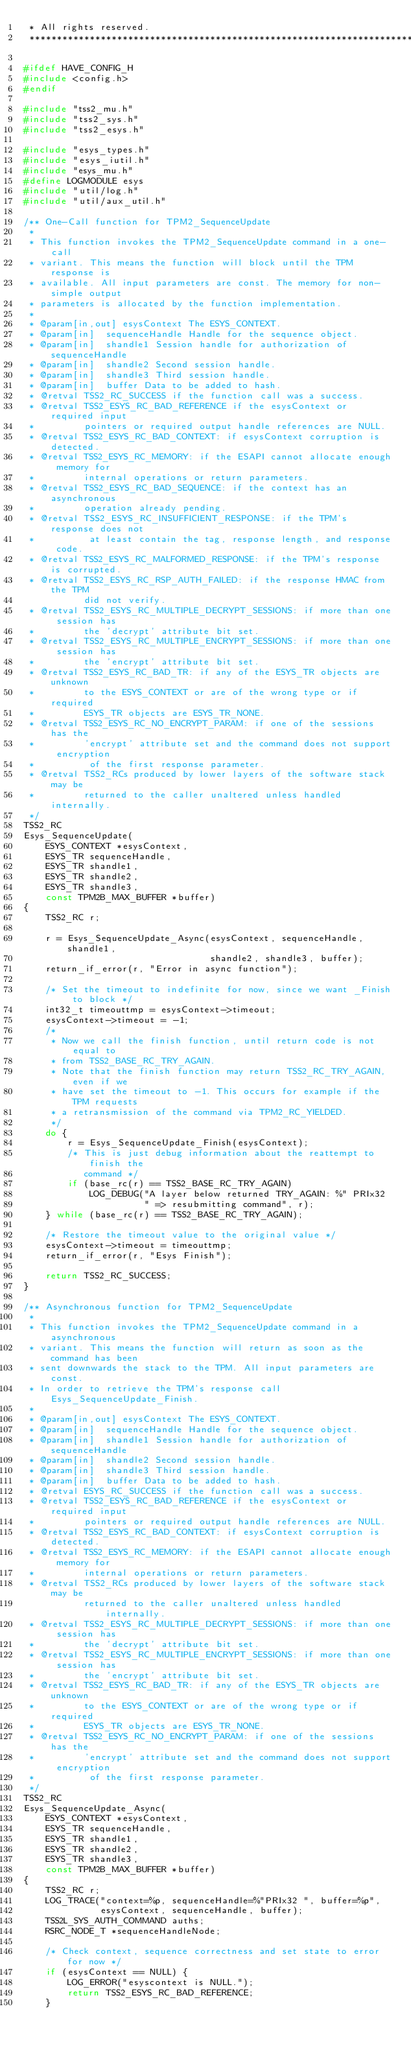<code> <loc_0><loc_0><loc_500><loc_500><_C_> * All rights reserved.
 ******************************************************************************/

#ifdef HAVE_CONFIG_H
#include <config.h>
#endif

#include "tss2_mu.h"
#include "tss2_sys.h"
#include "tss2_esys.h"

#include "esys_types.h"
#include "esys_iutil.h"
#include "esys_mu.h"
#define LOGMODULE esys
#include "util/log.h"
#include "util/aux_util.h"

/** One-Call function for TPM2_SequenceUpdate
 *
 * This function invokes the TPM2_SequenceUpdate command in a one-call
 * variant. This means the function will block until the TPM response is
 * available. All input parameters are const. The memory for non-simple output
 * parameters is allocated by the function implementation.
 *
 * @param[in,out] esysContext The ESYS_CONTEXT.
 * @param[in]  sequenceHandle Handle for the sequence object.
 * @param[in]  shandle1 Session handle for authorization of sequenceHandle
 * @param[in]  shandle2 Second session handle.
 * @param[in]  shandle3 Third session handle.
 * @param[in]  buffer Data to be added to hash.
 * @retval TSS2_RC_SUCCESS if the function call was a success.
 * @retval TSS2_ESYS_RC_BAD_REFERENCE if the esysContext or required input
 *         pointers or required output handle references are NULL.
 * @retval TSS2_ESYS_RC_BAD_CONTEXT: if esysContext corruption is detected.
 * @retval TSS2_ESYS_RC_MEMORY: if the ESAPI cannot allocate enough memory for
 *         internal operations or return parameters.
 * @retval TSS2_ESYS_RC_BAD_SEQUENCE: if the context has an asynchronous
 *         operation already pending.
 * @retval TSS2_ESYS_RC_INSUFFICIENT_RESPONSE: if the TPM's response does not
 *          at least contain the tag, response length, and response code.
 * @retval TSS2_ESYS_RC_MALFORMED_RESPONSE: if the TPM's response is corrupted.
 * @retval TSS2_ESYS_RC_RSP_AUTH_FAILED: if the response HMAC from the TPM
           did not verify.
 * @retval TSS2_ESYS_RC_MULTIPLE_DECRYPT_SESSIONS: if more than one session has
 *         the 'decrypt' attribute bit set.
 * @retval TSS2_ESYS_RC_MULTIPLE_ENCRYPT_SESSIONS: if more than one session has
 *         the 'encrypt' attribute bit set.
 * @retval TSS2_ESYS_RC_BAD_TR: if any of the ESYS_TR objects are unknown
 *         to the ESYS_CONTEXT or are of the wrong type or if required
 *         ESYS_TR objects are ESYS_TR_NONE.
 * @retval TSS2_ESYS_RC_NO_ENCRYPT_PARAM: if one of the sessions has the
 *         'encrypt' attribute set and the command does not support encryption
 *          of the first response parameter.
 * @retval TSS2_RCs produced by lower layers of the software stack may be
 *         returned to the caller unaltered unless handled internally.
 */
TSS2_RC
Esys_SequenceUpdate(
    ESYS_CONTEXT *esysContext,
    ESYS_TR sequenceHandle,
    ESYS_TR shandle1,
    ESYS_TR shandle2,
    ESYS_TR shandle3,
    const TPM2B_MAX_BUFFER *buffer)
{
    TSS2_RC r;

    r = Esys_SequenceUpdate_Async(esysContext, sequenceHandle, shandle1,
                                  shandle2, shandle3, buffer);
    return_if_error(r, "Error in async function");

    /* Set the timeout to indefinite for now, since we want _Finish to block */
    int32_t timeouttmp = esysContext->timeout;
    esysContext->timeout = -1;
    /*
     * Now we call the finish function, until return code is not equal to
     * from TSS2_BASE_RC_TRY_AGAIN.
     * Note that the finish function may return TSS2_RC_TRY_AGAIN, even if we
     * have set the timeout to -1. This occurs for example if the TPM requests
     * a retransmission of the command via TPM2_RC_YIELDED.
     */
    do {
        r = Esys_SequenceUpdate_Finish(esysContext);
        /* This is just debug information about the reattempt to finish the
           command */
        if (base_rc(r) == TSS2_BASE_RC_TRY_AGAIN)
            LOG_DEBUG("A layer below returned TRY_AGAIN: %" PRIx32
                      " => resubmitting command", r);
    } while (base_rc(r) == TSS2_BASE_RC_TRY_AGAIN);

    /* Restore the timeout value to the original value */
    esysContext->timeout = timeouttmp;
    return_if_error(r, "Esys Finish");

    return TSS2_RC_SUCCESS;
}

/** Asynchronous function for TPM2_SequenceUpdate
 *
 * This function invokes the TPM2_SequenceUpdate command in a asynchronous
 * variant. This means the function will return as soon as the command has been
 * sent downwards the stack to the TPM. All input parameters are const.
 * In order to retrieve the TPM's response call Esys_SequenceUpdate_Finish.
 *
 * @param[in,out] esysContext The ESYS_CONTEXT.
 * @param[in]  sequenceHandle Handle for the sequence object.
 * @param[in]  shandle1 Session handle for authorization of sequenceHandle
 * @param[in]  shandle2 Second session handle.
 * @param[in]  shandle3 Third session handle.
 * @param[in]  buffer Data to be added to hash.
 * @retval ESYS_RC_SUCCESS if the function call was a success.
 * @retval TSS2_ESYS_RC_BAD_REFERENCE if the esysContext or required input
 *         pointers or required output handle references are NULL.
 * @retval TSS2_ESYS_RC_BAD_CONTEXT: if esysContext corruption is detected.
 * @retval TSS2_ESYS_RC_MEMORY: if the ESAPI cannot allocate enough memory for
 *         internal operations or return parameters.
 * @retval TSS2_RCs produced by lower layers of the software stack may be
           returned to the caller unaltered unless handled internally.
 * @retval TSS2_ESYS_RC_MULTIPLE_DECRYPT_SESSIONS: if more than one session has
 *         the 'decrypt' attribute bit set.
 * @retval TSS2_ESYS_RC_MULTIPLE_ENCRYPT_SESSIONS: if more than one session has
 *         the 'encrypt' attribute bit set.
 * @retval TSS2_ESYS_RC_BAD_TR: if any of the ESYS_TR objects are unknown
 *         to the ESYS_CONTEXT or are of the wrong type or if required
 *         ESYS_TR objects are ESYS_TR_NONE.
 * @retval TSS2_ESYS_RC_NO_ENCRYPT_PARAM: if one of the sessions has the
 *         'encrypt' attribute set and the command does not support encryption
 *          of the first response parameter.
 */
TSS2_RC
Esys_SequenceUpdate_Async(
    ESYS_CONTEXT *esysContext,
    ESYS_TR sequenceHandle,
    ESYS_TR shandle1,
    ESYS_TR shandle2,
    ESYS_TR shandle3,
    const TPM2B_MAX_BUFFER *buffer)
{
    TSS2_RC r;
    LOG_TRACE("context=%p, sequenceHandle=%"PRIx32 ", buffer=%p",
              esysContext, sequenceHandle, buffer);
    TSS2L_SYS_AUTH_COMMAND auths;
    RSRC_NODE_T *sequenceHandleNode;

    /* Check context, sequence correctness and set state to error for now */
    if (esysContext == NULL) {
        LOG_ERROR("esyscontext is NULL.");
        return TSS2_ESYS_RC_BAD_REFERENCE;
    }</code> 